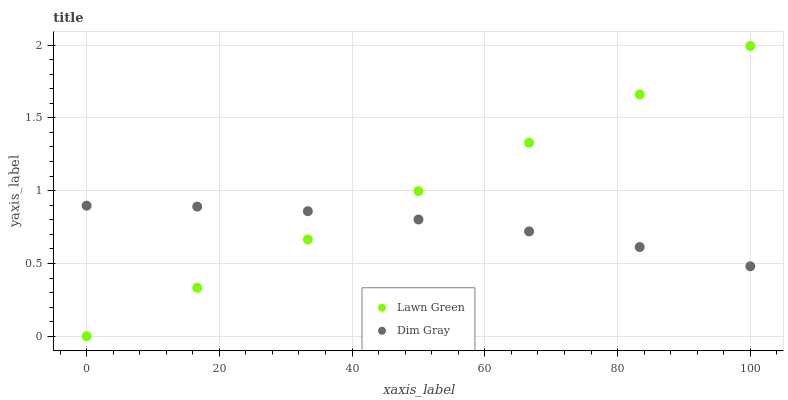Does Dim Gray have the minimum area under the curve?
Answer yes or no. Yes. Does Lawn Green have the maximum area under the curve?
Answer yes or no. Yes. Does Dim Gray have the maximum area under the curve?
Answer yes or no. No. Is Lawn Green the smoothest?
Answer yes or no. Yes. Is Dim Gray the roughest?
Answer yes or no. Yes. Is Dim Gray the smoothest?
Answer yes or no. No. Does Lawn Green have the lowest value?
Answer yes or no. Yes. Does Dim Gray have the lowest value?
Answer yes or no. No. Does Lawn Green have the highest value?
Answer yes or no. Yes. Does Dim Gray have the highest value?
Answer yes or no. No. Does Lawn Green intersect Dim Gray?
Answer yes or no. Yes. Is Lawn Green less than Dim Gray?
Answer yes or no. No. Is Lawn Green greater than Dim Gray?
Answer yes or no. No. 